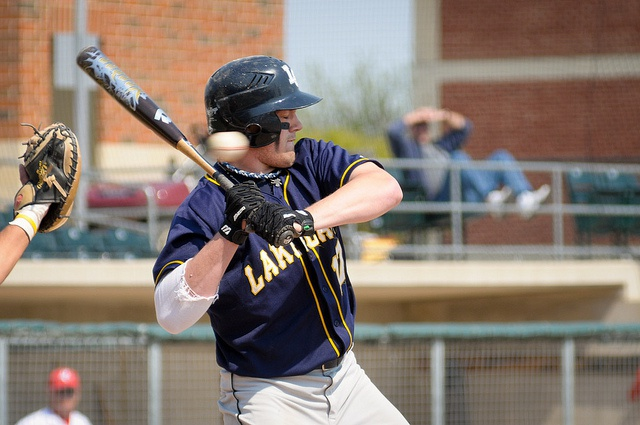Describe the objects in this image and their specific colors. I can see people in brown, black, lightgray, gray, and navy tones, people in brown, gray, and darkgray tones, baseball glove in brown, black, gray, ivory, and tan tones, bench in brown, black, gray, and blue tones, and baseball bat in brown, gray, darkgray, black, and lightgray tones in this image. 